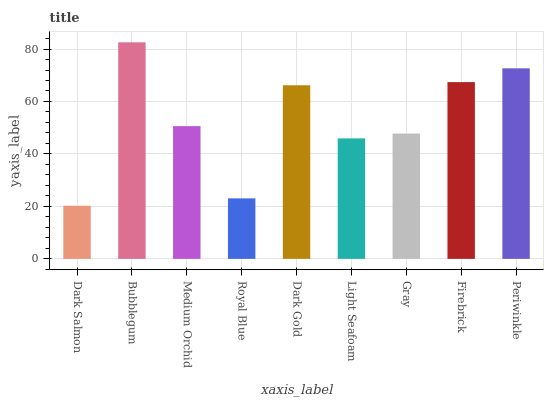Is Dark Salmon the minimum?
Answer yes or no. Yes. Is Bubblegum the maximum?
Answer yes or no. Yes. Is Medium Orchid the minimum?
Answer yes or no. No. Is Medium Orchid the maximum?
Answer yes or no. No. Is Bubblegum greater than Medium Orchid?
Answer yes or no. Yes. Is Medium Orchid less than Bubblegum?
Answer yes or no. Yes. Is Medium Orchid greater than Bubblegum?
Answer yes or no. No. Is Bubblegum less than Medium Orchid?
Answer yes or no. No. Is Medium Orchid the high median?
Answer yes or no. Yes. Is Medium Orchid the low median?
Answer yes or no. Yes. Is Light Seafoam the high median?
Answer yes or no. No. Is Royal Blue the low median?
Answer yes or no. No. 